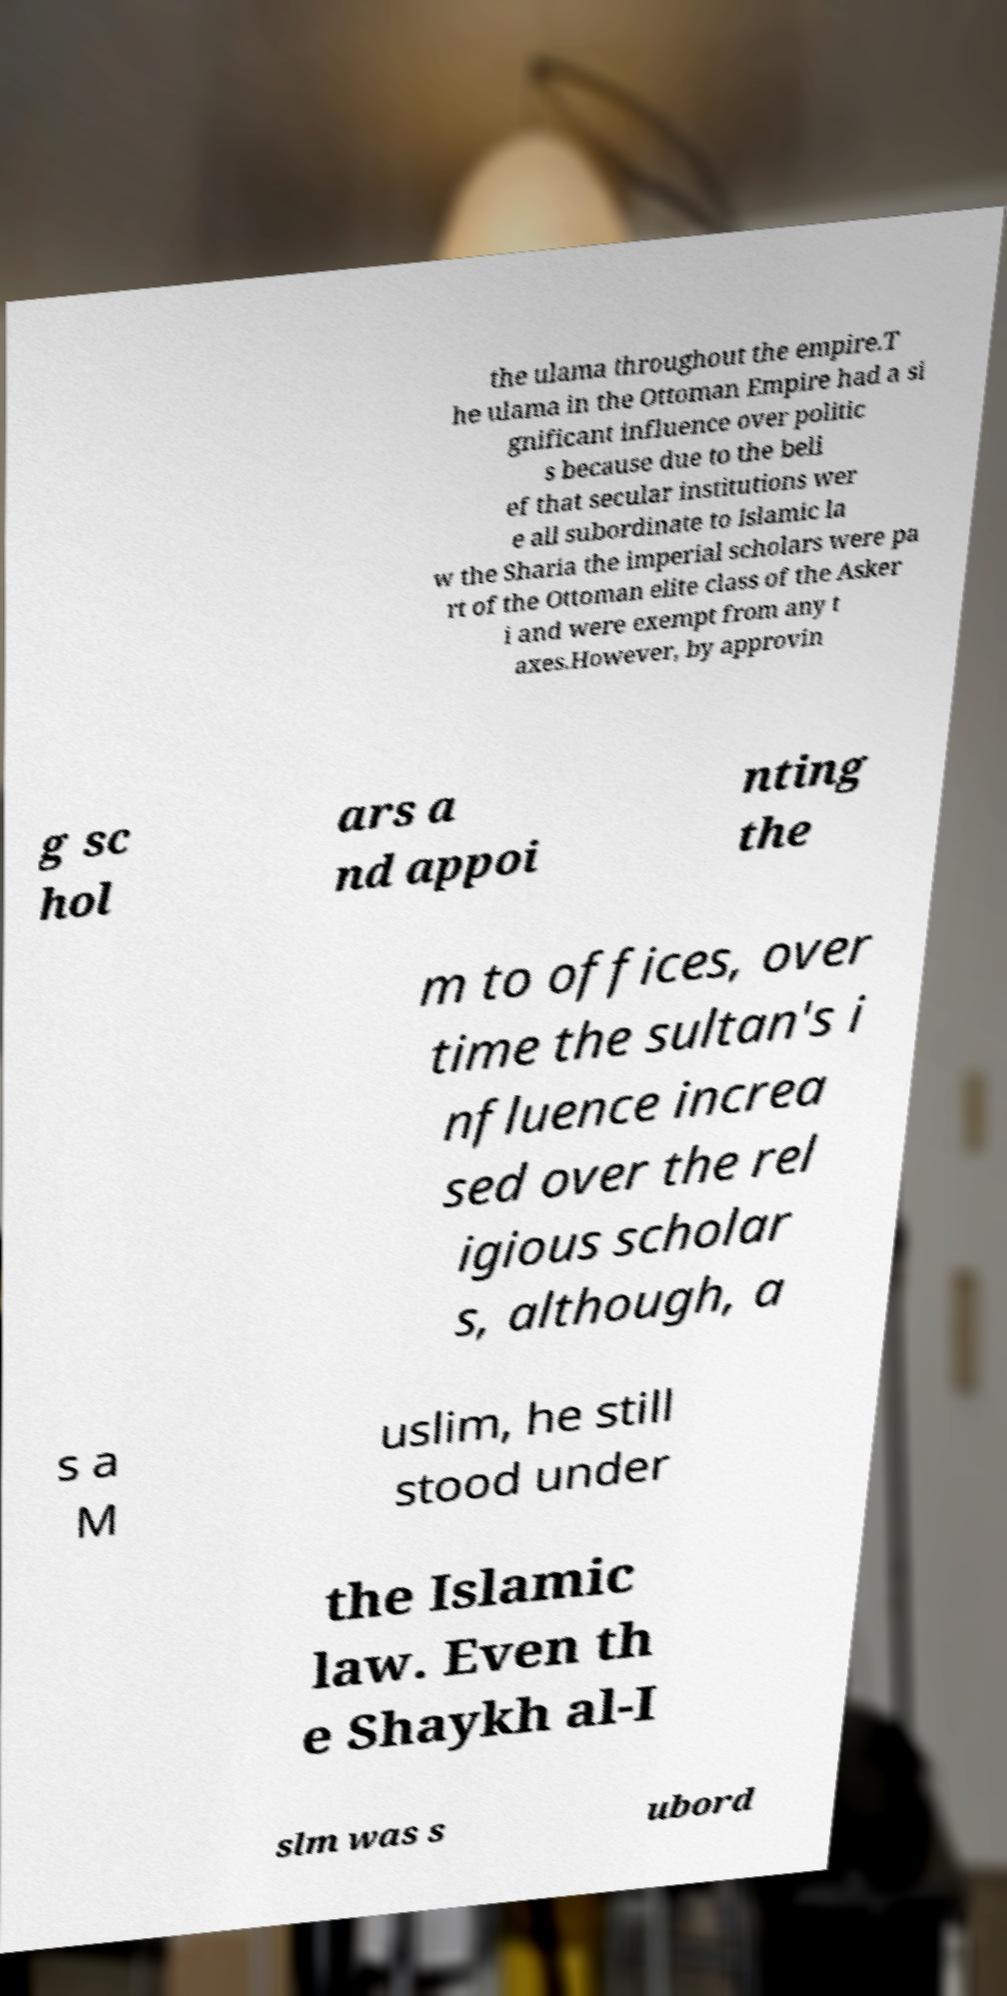What messages or text are displayed in this image? I need them in a readable, typed format. the ulama throughout the empire.T he ulama in the Ottoman Empire had a si gnificant influence over politic s because due to the beli ef that secular institutions wer e all subordinate to Islamic la w the Sharia the imperial scholars were pa rt of the Ottoman elite class of the Asker i and were exempt from any t axes.However, by approvin g sc hol ars a nd appoi nting the m to offices, over time the sultan's i nfluence increa sed over the rel igious scholar s, although, a s a M uslim, he still stood under the Islamic law. Even th e Shaykh al-I slm was s ubord 